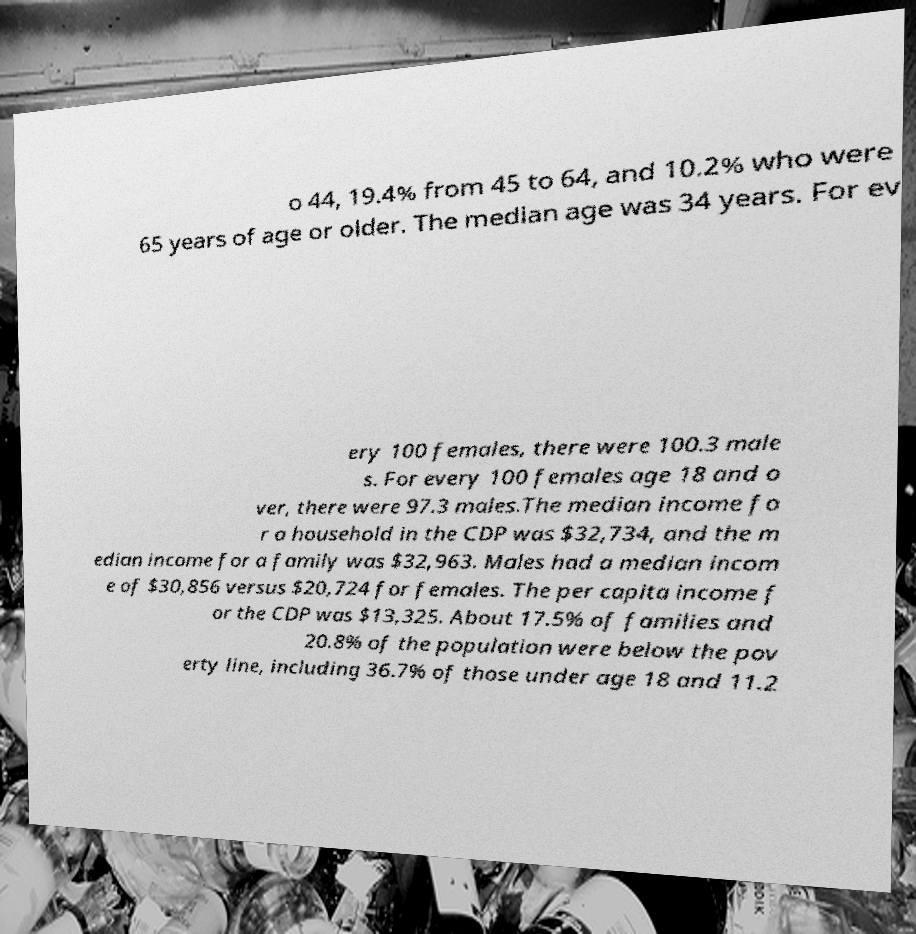I need the written content from this picture converted into text. Can you do that? o 44, 19.4% from 45 to 64, and 10.2% who were 65 years of age or older. The median age was 34 years. For ev ery 100 females, there were 100.3 male s. For every 100 females age 18 and o ver, there were 97.3 males.The median income fo r a household in the CDP was $32,734, and the m edian income for a family was $32,963. Males had a median incom e of $30,856 versus $20,724 for females. The per capita income f or the CDP was $13,325. About 17.5% of families and 20.8% of the population were below the pov erty line, including 36.7% of those under age 18 and 11.2 